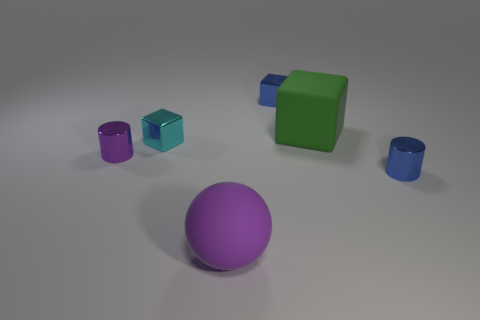There is a cyan thing that is made of the same material as the purple cylinder; what is its shape?
Give a very brief answer. Cube. Is the size of the block behind the matte cube the same as the green matte cube that is behind the small cyan metallic object?
Your answer should be compact. No. Are there more small purple metal cylinders on the left side of the tiny purple metallic object than small cyan metallic objects behind the purple matte ball?
Provide a short and direct response. No. What number of other objects are there of the same color as the big ball?
Offer a terse response. 1. Is the color of the sphere the same as the thing left of the cyan metal cube?
Offer a very short reply. Yes. How many objects are in front of the blue shiny object left of the blue cylinder?
Make the answer very short. 5. What material is the big purple sphere that is in front of the small shiny cylinder on the left side of the tiny block that is on the right side of the small cyan shiny thing?
Your answer should be compact. Rubber. What is the material of the thing that is both in front of the purple cylinder and on the left side of the large cube?
Your response must be concise. Rubber. What number of cyan things have the same shape as the green rubber thing?
Provide a succinct answer. 1. There is a shiny cylinder that is on the left side of the large object that is in front of the green cube; how big is it?
Your answer should be very brief. Small. 